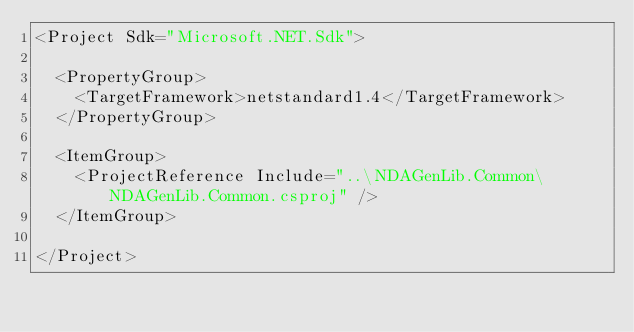Convert code to text. <code><loc_0><loc_0><loc_500><loc_500><_XML_><Project Sdk="Microsoft.NET.Sdk">

  <PropertyGroup>
    <TargetFramework>netstandard1.4</TargetFramework>
  </PropertyGroup>

  <ItemGroup>
    <ProjectReference Include="..\NDAGenLib.Common\NDAGenLib.Common.csproj" />
  </ItemGroup>

</Project>
</code> 